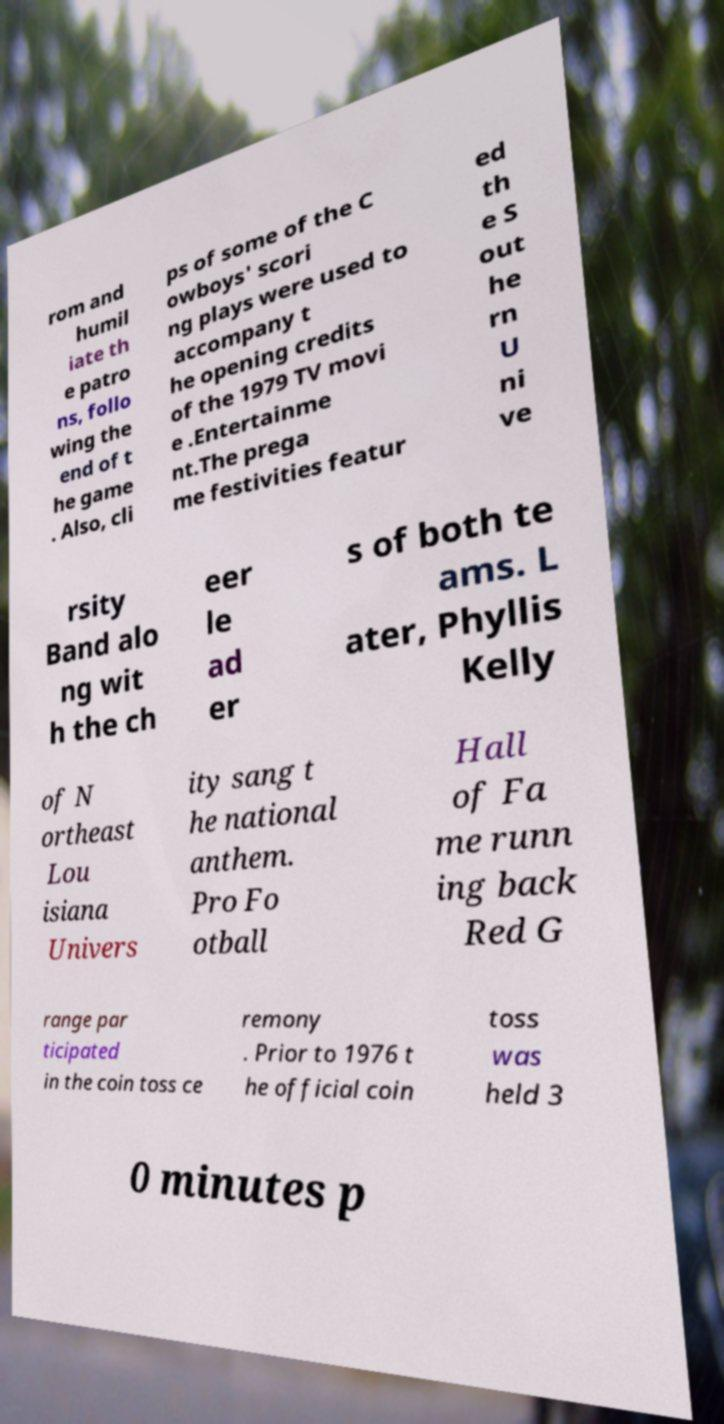Could you assist in decoding the text presented in this image and type it out clearly? rom and humil iate th e patro ns, follo wing the end of t he game . Also, cli ps of some of the C owboys' scori ng plays were used to accompany t he opening credits of the 1979 TV movi e .Entertainme nt.The prega me festivities featur ed th e S out he rn U ni ve rsity Band alo ng wit h the ch eer le ad er s of both te ams. L ater, Phyllis Kelly of N ortheast Lou isiana Univers ity sang t he national anthem. Pro Fo otball Hall of Fa me runn ing back Red G range par ticipated in the coin toss ce remony . Prior to 1976 t he official coin toss was held 3 0 minutes p 